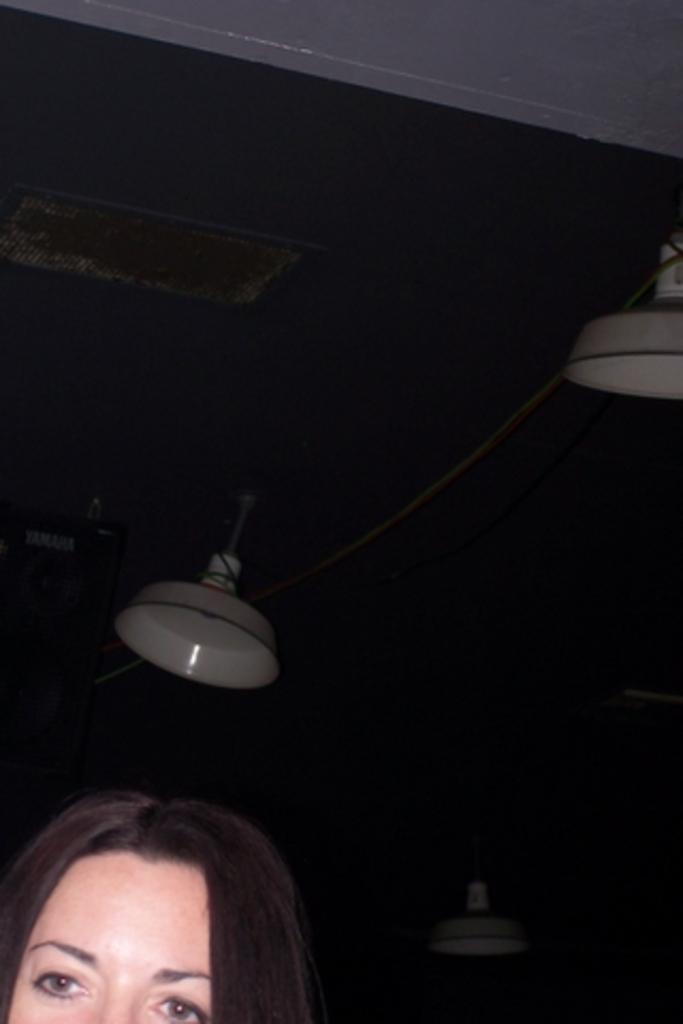Could you give a brief overview of what you see in this image? At the bottom of the image there is a woman. At the top of the image there is ceiling with some objects. 